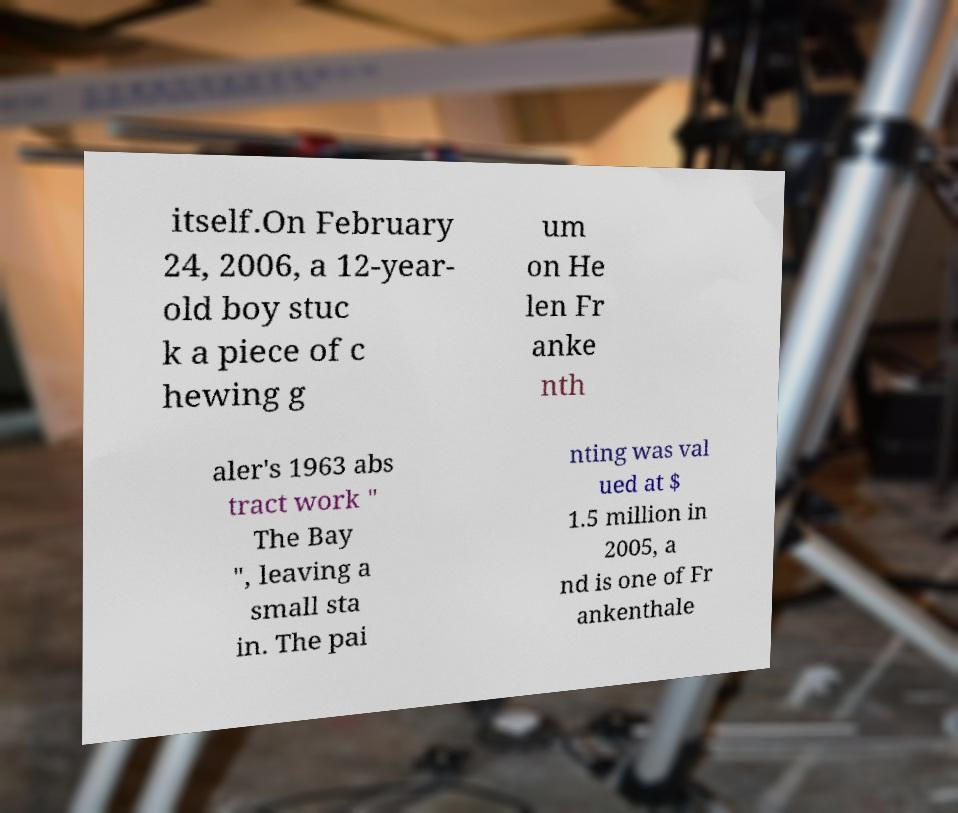Could you extract and type out the text from this image? itself.On February 24, 2006, a 12-year- old boy stuc k a piece of c hewing g um on He len Fr anke nth aler's 1963 abs tract work " The Bay ", leaving a small sta in. The pai nting was val ued at $ 1.5 million in 2005, a nd is one of Fr ankenthale 